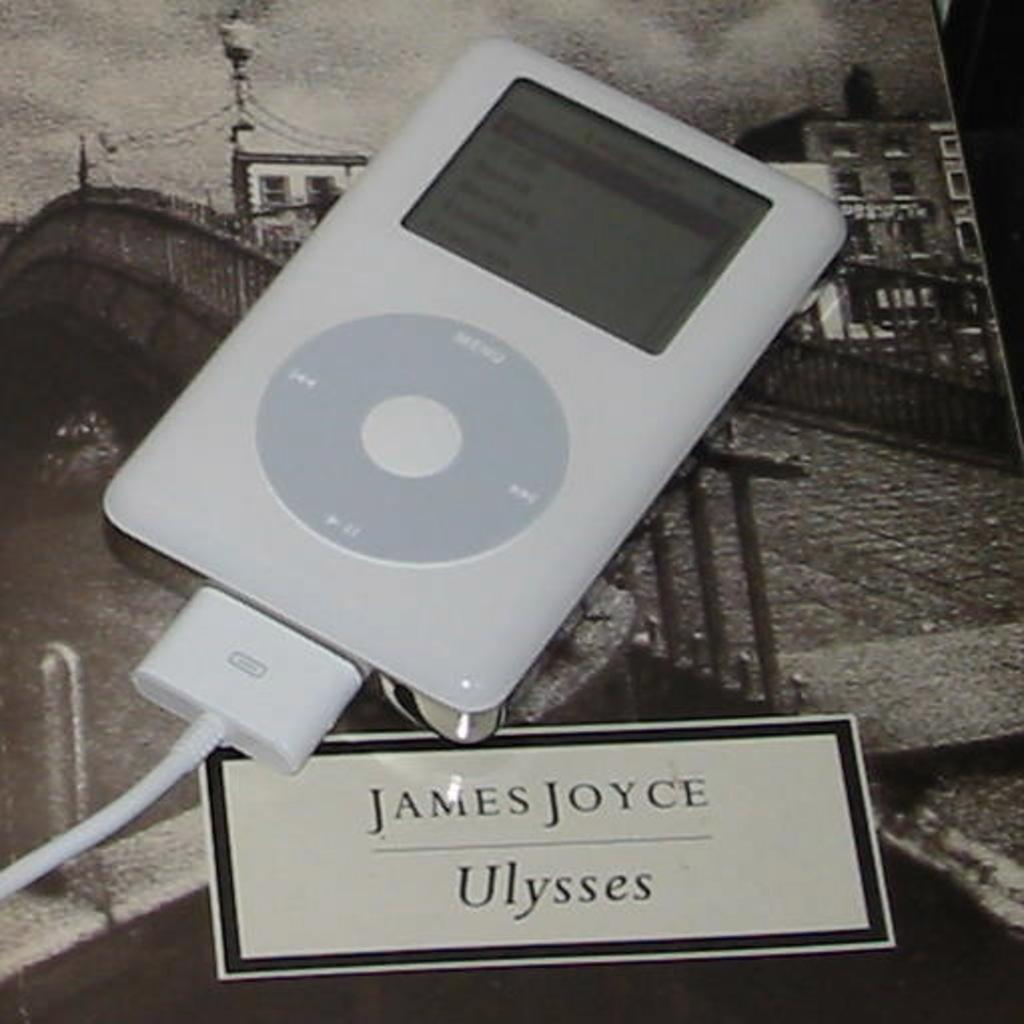What electronic device is visible in the image? There is an iPod in the image. What is connected to the iPod in the image? There is a cable in the image. What type of paper item is present in the image? There is a card in the image. What can be seen in the background of the image? There is a picture of a building, a board, a fence, and a light in the background. What type of plough is being used to control the iPod in the image? There is no plough present in the image, and the iPod is not being controlled by any agricultural equipment. 